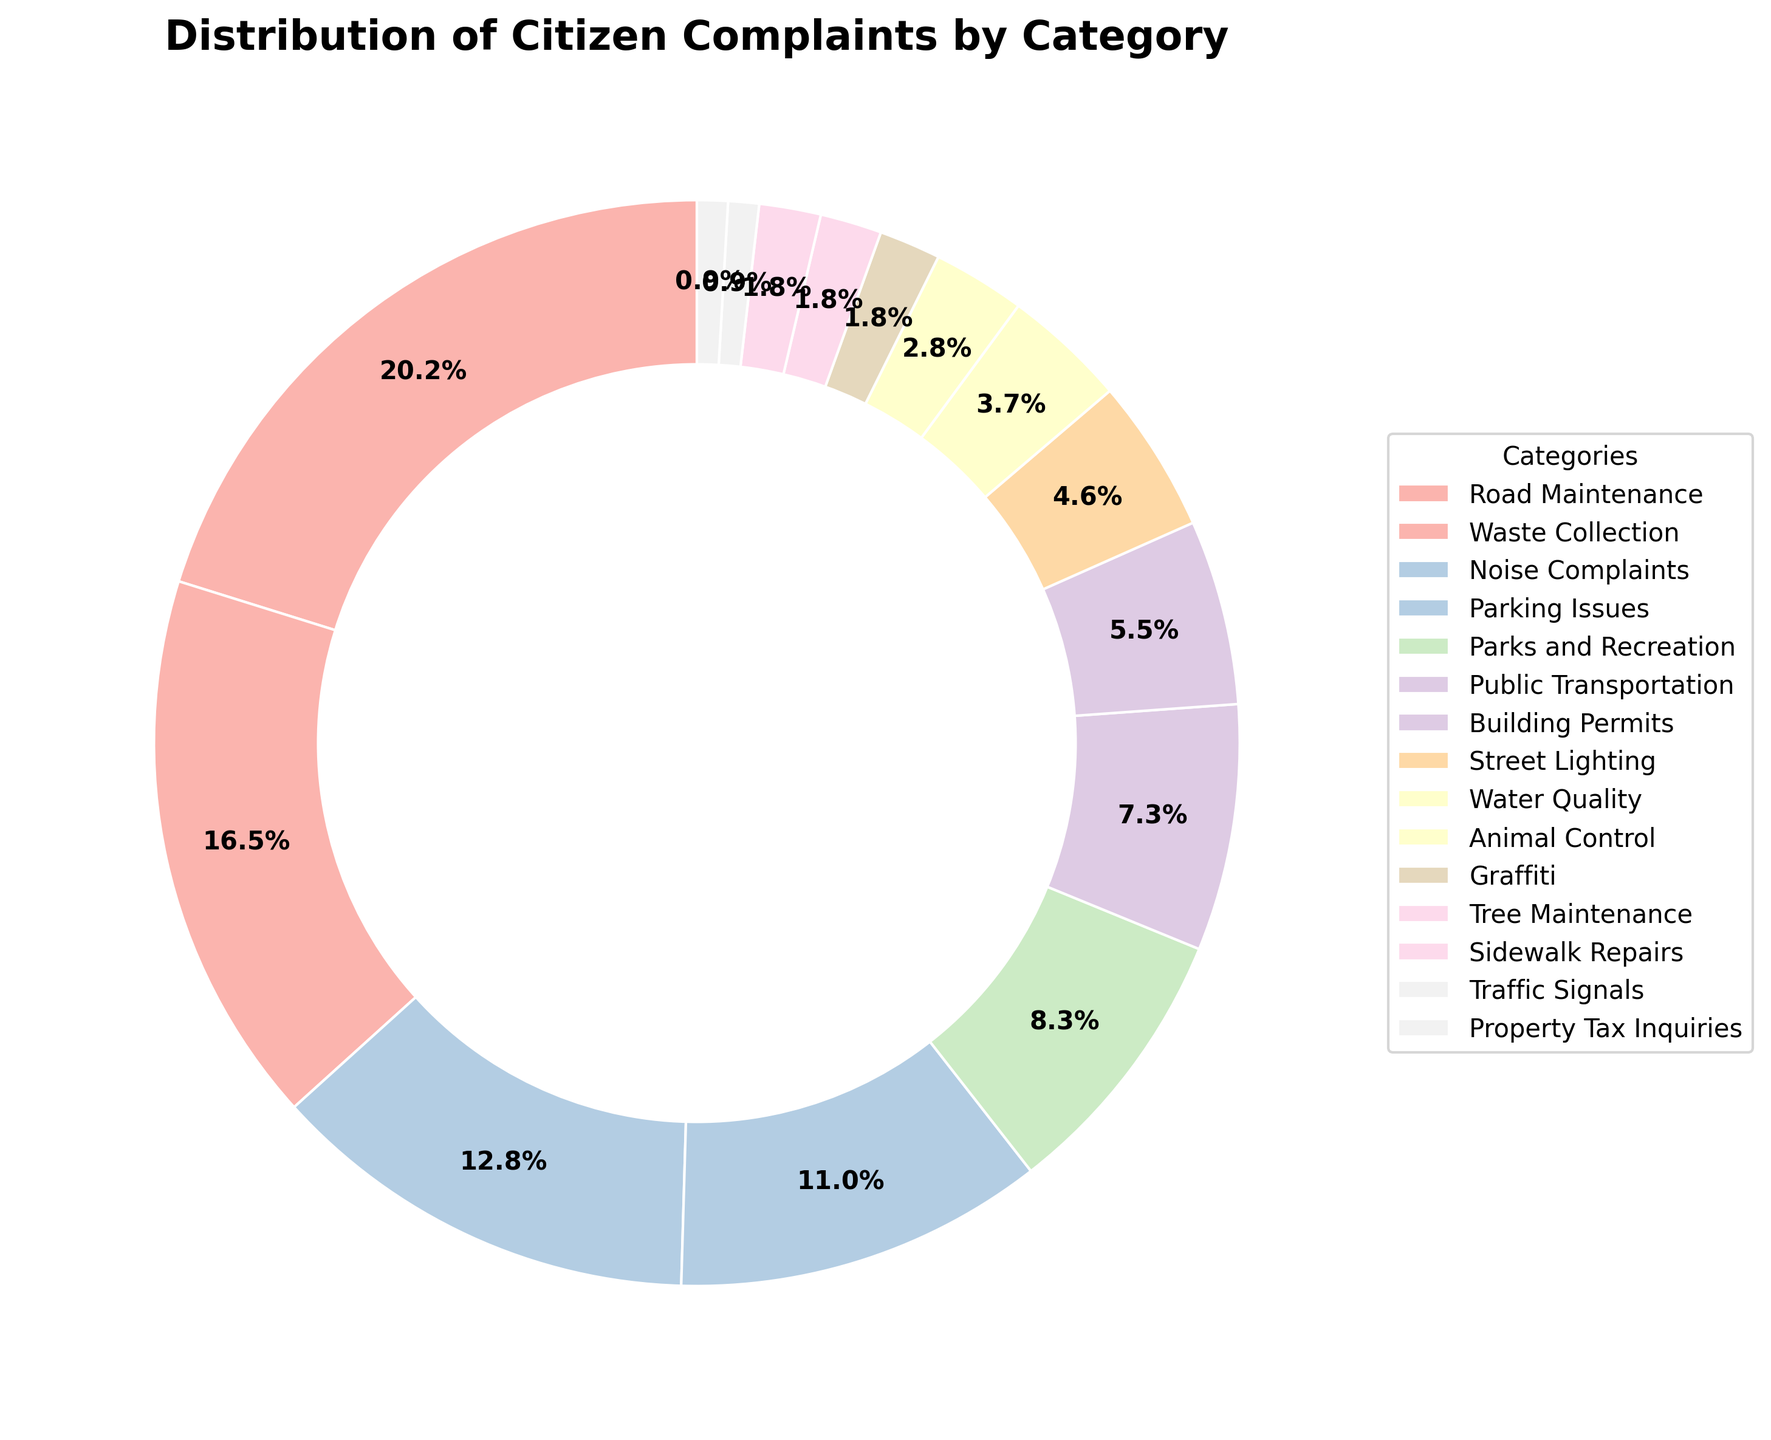What percentage of complaints are related to road maintenance? Locate 'Road Maintenance' segment and see its percentage value on the pie chart.
Answer: 22% Which category has the least share of complaints? Identify the smallest segment in the pie chart and check its label.
Answer: Property Tax Inquiries Are complaints about Building Permits more or less than those about Waste Collection? By how much? Check the percentage values for 'Building Permits' and 'Waste Collection'. Subtract the smaller percentage from the larger.
Answer: 12% less What is the combined percentage of complaints for Traffic Signals, Sidewalk Repairs, and Tree Maintenance? Sum the percentages of 'Traffic Signals', 'Sidewalk Repairs', and 'Tree Maintenance' from the pie chart.
Answer: 5% Which category has a higher percentage of complaints: Parks and Recreation or Public Transportation? Compare the percentage values for 'Parks and Recreation' and 'Public Transportation'.
Answer: Parks and Recreation What is the median percentage value of all complaint categories? List all percentages in ascending order: 1, 1, 2, 2, 2, 3, 4, 5, 6, 8, 9, 12, 14, 18, 22. The median is the middle value.
Answer: 5% By what percentage is Noise Complaints greater than Animal Control complaints? Subtract the percentage of 'Animal Control' from 'Noise Complaints'.
Answer: 11% Which categories combined account for more than 50% of the complaints? Sum the percentages starting from the largest until the sum exceeds 50%.
Answer: Road Maintenance and Waste Collection What is the average percentage of the categories with more than 10% of the complaints? Identify categories with percentages above 10%: Road Maintenance, Waste Collection, Noise Complaints, Parking Issues. Calculate their average: (22 + 18 + 14 + 12)/4.
Answer: 16.5% 